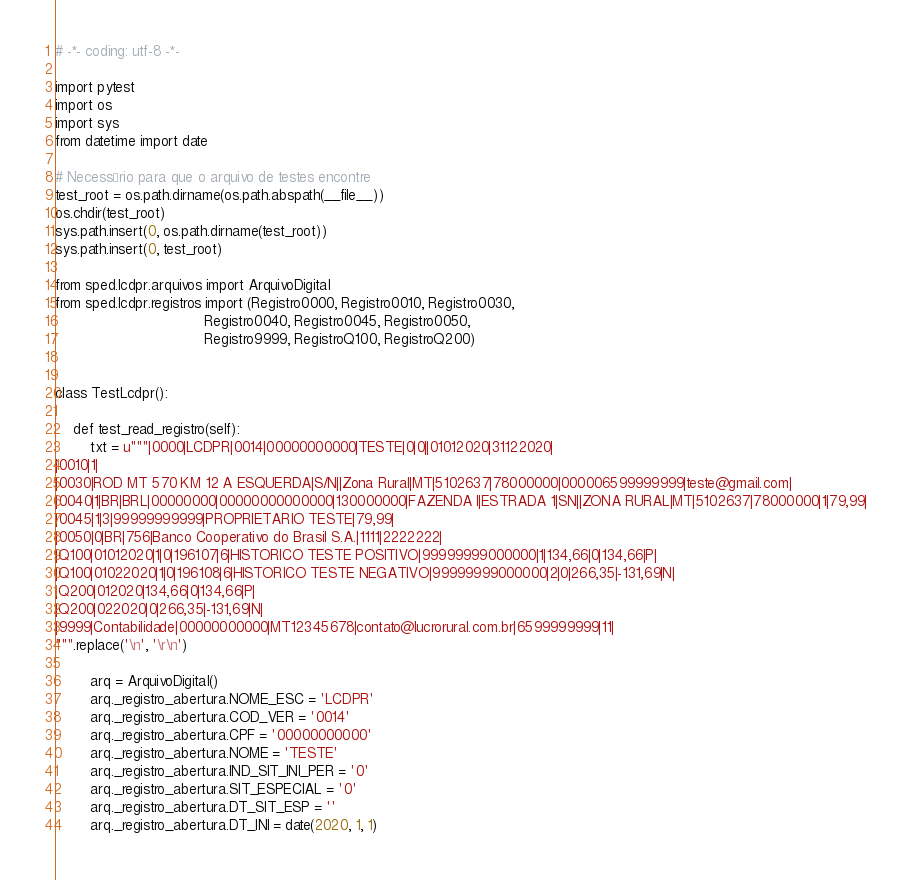<code> <loc_0><loc_0><loc_500><loc_500><_Python_># -*- coding: utf-8 -*-

import pytest
import os
import sys
from datetime import date

# Necessário para que o arquivo de testes encontre
test_root = os.path.dirname(os.path.abspath(__file__))
os.chdir(test_root)
sys.path.insert(0, os.path.dirname(test_root))
sys.path.insert(0, test_root)

from sped.lcdpr.arquivos import ArquivoDigital
from sped.lcdpr.registros import (Registro0000, Registro0010, Registro0030,
                                  Registro0040, Registro0045, Registro0050,
                                  Registro9999, RegistroQ100, RegistroQ200)


class TestLcdpr():

    def test_read_registro(self):
        txt = u"""|0000|LCDPR|0014|00000000000|TESTE|0|0||01012020|31122020|
|0010|1|
|0030|ROD MT 570 KM 12 A ESQUERDA|S/N||Zona Rural|MT|5102637|78000000|000006599999999|teste@gmail.com|
|0040|1|BR|BRL|00000000|00000000000000|130000000|FAZENDA I|ESTRADA 1|SN||ZONA RURAL|MT|5102637|78000000|1|79,99|
|0045|1|3|99999999999|PROPRIETARIO TESTE|79,99|
|0050|0|BR|756|Banco Cooperativo do Brasil S.A.|1111|2222222|
|Q100|01012020|1|0|196107|6|HISTORICO TESTE POSITIVO|99999999000000|1|134,66|0|134,66|P|
|Q100|01022020|1|0|196108|6|HISTORICO TESTE NEGATIVO|99999999000000|2|0|266,35|-131,69|N|
|Q200|012020|134,66|0|134,66|P|
|Q200|022020|0|266,35|-131,69|N|
|9999|Contabilidade|00000000000|MT12345678|contato@lucrorural.com.br|6599999999|11|
""".replace('\n', '\r\n')

        arq = ArquivoDigital()
        arq._registro_abertura.NOME_ESC = 'LCDPR'
        arq._registro_abertura.COD_VER = '0014'
        arq._registro_abertura.CPF = '00000000000'
        arq._registro_abertura.NOME = 'TESTE'
        arq._registro_abertura.IND_SIT_INI_PER = '0'
        arq._registro_abertura.SIT_ESPECIAL = '0'
        arq._registro_abertura.DT_SIT_ESP = ''
        arq._registro_abertura.DT_INI = date(2020, 1, 1)</code> 